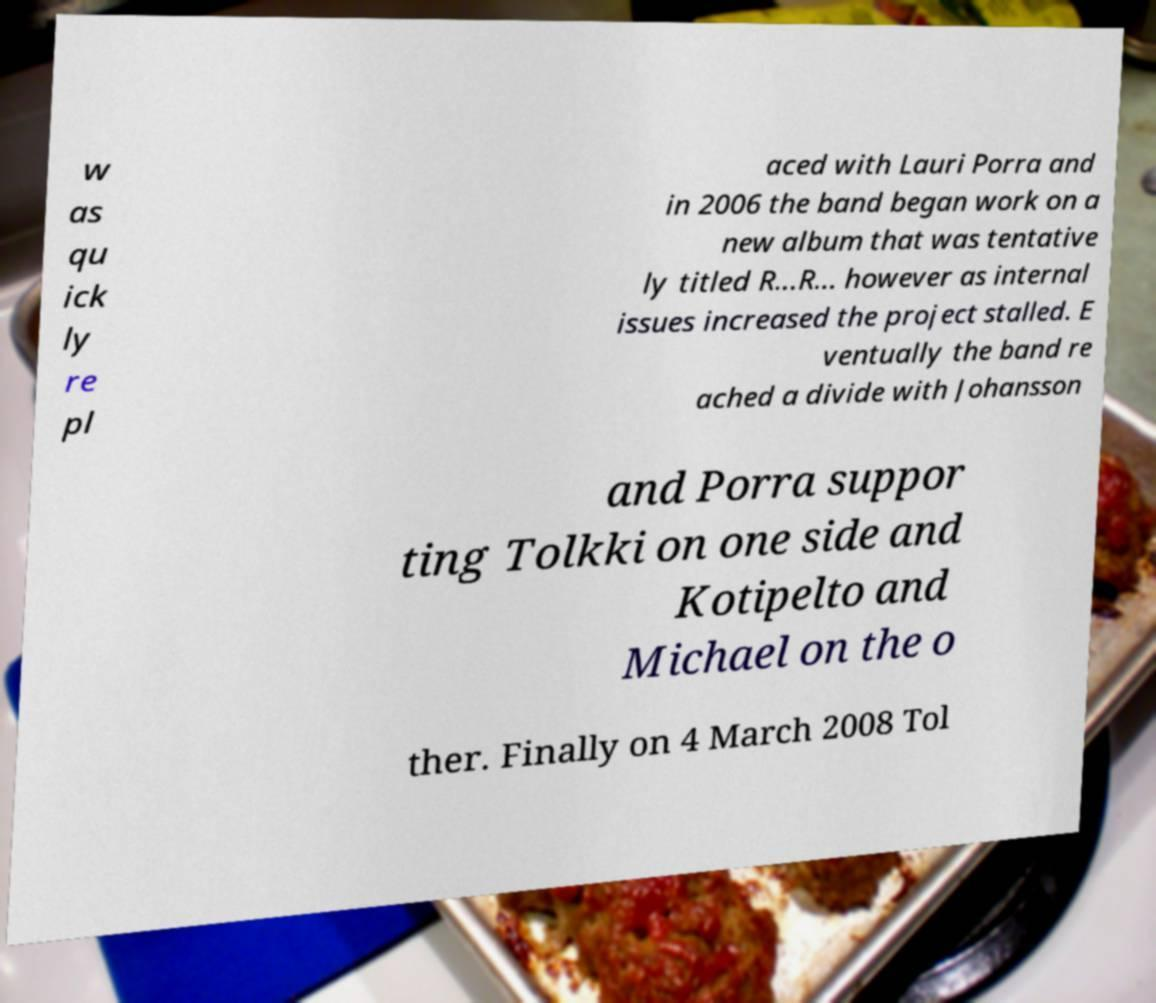Please identify and transcribe the text found in this image. w as qu ick ly re pl aced with Lauri Porra and in 2006 the band began work on a new album that was tentative ly titled R...R... however as internal issues increased the project stalled. E ventually the band re ached a divide with Johansson and Porra suppor ting Tolkki on one side and Kotipelto and Michael on the o ther. Finally on 4 March 2008 Tol 